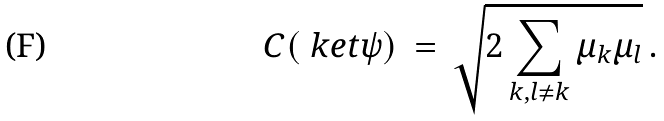Convert formula to latex. <formula><loc_0><loc_0><loc_500><loc_500>C ( \ k e t { \psi } ) \, = \, \sqrt { 2 \sum _ { k , l \neq k } \mu _ { k } \mu _ { l } } \, .</formula> 